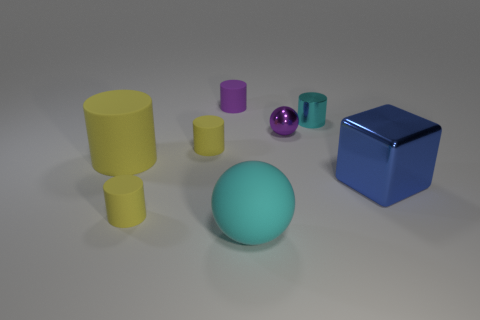How many objects are purple metal spheres or tiny cyan shiny things?
Give a very brief answer. 2. There is a small yellow cylinder right of the small yellow cylinder that is in front of the big blue object; what is its material?
Your answer should be compact. Rubber. Is there a shiny block that has the same color as the metallic sphere?
Provide a short and direct response. No. There is a metallic cube that is the same size as the cyan rubber sphere; what is its color?
Keep it short and to the point. Blue. What is the small purple object that is on the right side of the small purple cylinder left of the small metallic object that is on the left side of the cyan metal cylinder made of?
Ensure brevity in your answer.  Metal. There is a big matte cylinder; is its color the same as the tiny shiny cylinder that is behind the large blue block?
Ensure brevity in your answer.  No. What number of things are things in front of the big metal object or spheres on the right side of the big rubber sphere?
Provide a short and direct response. 3. What is the shape of the cyan object that is behind the cyan thing on the left side of the cyan cylinder?
Make the answer very short. Cylinder. Are there any cyan spheres that have the same material as the tiny cyan cylinder?
Your answer should be compact. No. What is the color of the small metallic thing that is the same shape as the purple rubber thing?
Your answer should be very brief. Cyan. 